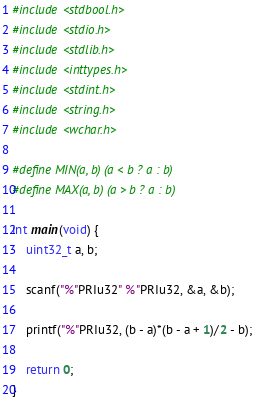Convert code to text. <code><loc_0><loc_0><loc_500><loc_500><_C_>#include <stdbool.h>
#include <stdio.h>
#include <stdlib.h>
#include <inttypes.h>
#include <stdint.h>
#include <string.h>
#include <wchar.h>

#define MIN(a, b) (a < b ? a : b)
#define MAX(a, b) (a > b ? a : b)

int main(void) {
	uint32_t a, b;

	scanf("%"PRIu32" %"PRIu32, &a, &b);

	printf("%"PRIu32, (b - a)*(b - a + 1)/2 - b);

	return 0;
}
</code> 